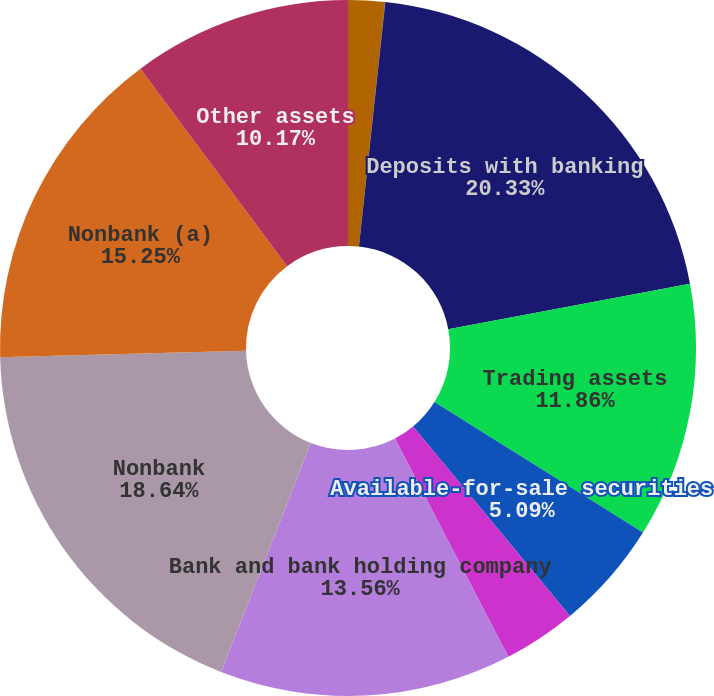Convert chart. <chart><loc_0><loc_0><loc_500><loc_500><pie_chart><fcel>December 31 (in millions)<fcel>Cash and due from banks<fcel>Deposits with banking<fcel>Trading assets<fcel>Available-for-sale securities<fcel>Loans<fcel>Bank and bank holding company<fcel>Nonbank<fcel>Nonbank (a)<fcel>Other assets<nl><fcel>1.7%<fcel>0.01%<fcel>20.33%<fcel>11.86%<fcel>5.09%<fcel>3.39%<fcel>13.56%<fcel>18.64%<fcel>15.25%<fcel>10.17%<nl></chart> 